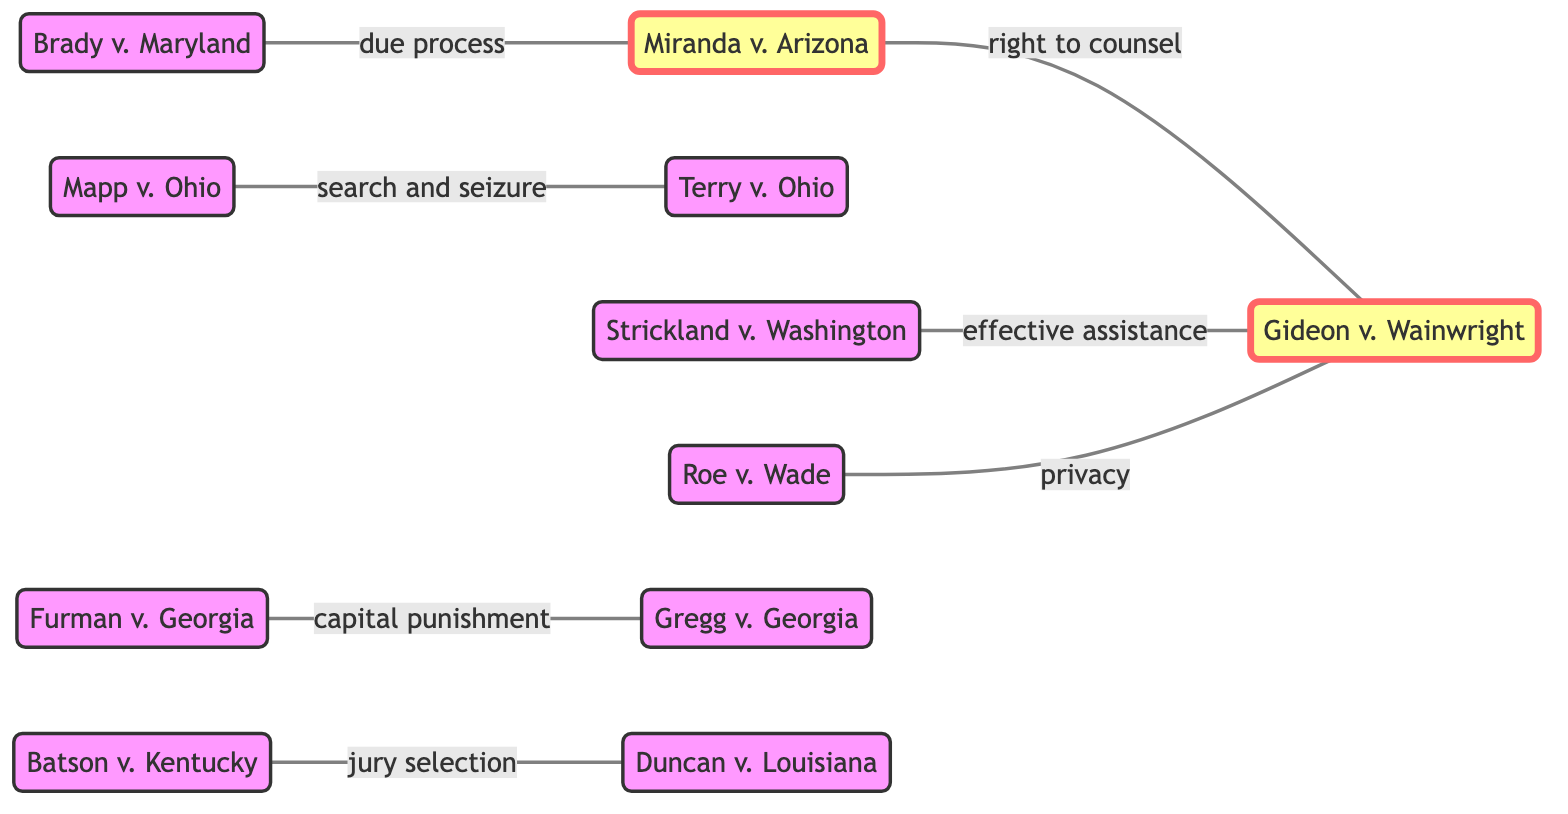What are the total number of nodes in the diagram? By counting the nodes listed in the diagram, we can see there are 11 nodes: Miranda v. Arizona, Gideon v. Wainwright, Mapp v. Ohio, Terry v. Ohio, Strickland v. Washington, Batson v. Kentucky, Brady v. Maryland, Roe v. Wade, Furman v. Georgia, Gregg v. Georgia, and Duncan v. Louisiana.
Answer: 11 What relationship exists between Gideon v. Wainwright and Strickland v. Washington? The link between Gideon v. Wainwright and Strickland v. Washington is labeled as "effective assistance." This can be observed by following the direct connection between these two nodes in the diagram.
Answer: effective assistance Which two cases are directly connected to Miranda v. Arizona? The cases that are directly connected to Miranda v. Arizona are Gideon v. Wainwright and Brady v. Maryland. This is evident from the links that connect Miranda v. Arizona to these two cases.
Answer: Gideon v. Wainwright, Brady v. Maryland Which case addresses the issue of capital punishment? The case that addresses the issue of capital punishment is Gregg v. Georgia, which is directly connected to Furman v. Georgia denoted by the label "capital punishment."
Answer: Gregg v. Georgia What is the connecting label between Batson v. Kentucky and Duncan v. Louisiana? The connecting label between Batson v. Kentucky and Duncan v. Louisiana is "jury selection," indicating the nature of their relationship in the context of legal precedents.
Answer: jury selection How many cases are connected to Gideon v. Wainwright? Gideon v. Wainwright is connected to three cases: Miranda v. Arizona, Strickland v. Washington, and Roe v. Wade. Counting these connections reveals the extent of legal precedents involving this case.
Answer: 3 What is the relationship between Mapp v. Ohio and Terry v. Ohio? The relationship between Mapp v. Ohio and Terry v. Ohio is described by the label "search and seizure," indicating the thematic connection regarding legal interpretations in criminal law.
Answer: search and seizure Which node is the only one connected to Roe v. Wade? Roe v. Wade is solely connected to Gideon v. Wainwright, indicating a specific legal relationship solely with that case in the diagram.
Answer: Gideon v. Wainwright 